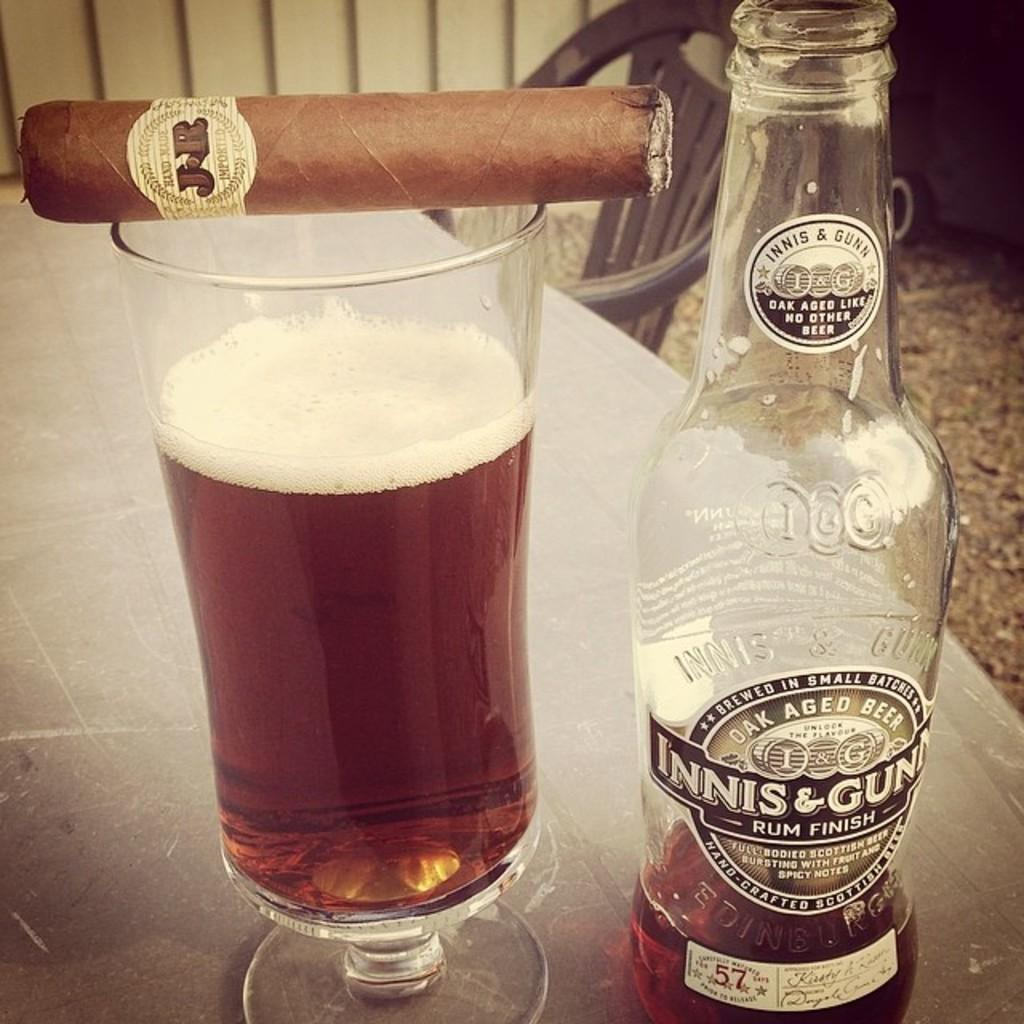<image>
Write a terse but informative summary of the picture. A mostly empty bottle of oak aged beer sits next to a glass with a cigar on top of it. 